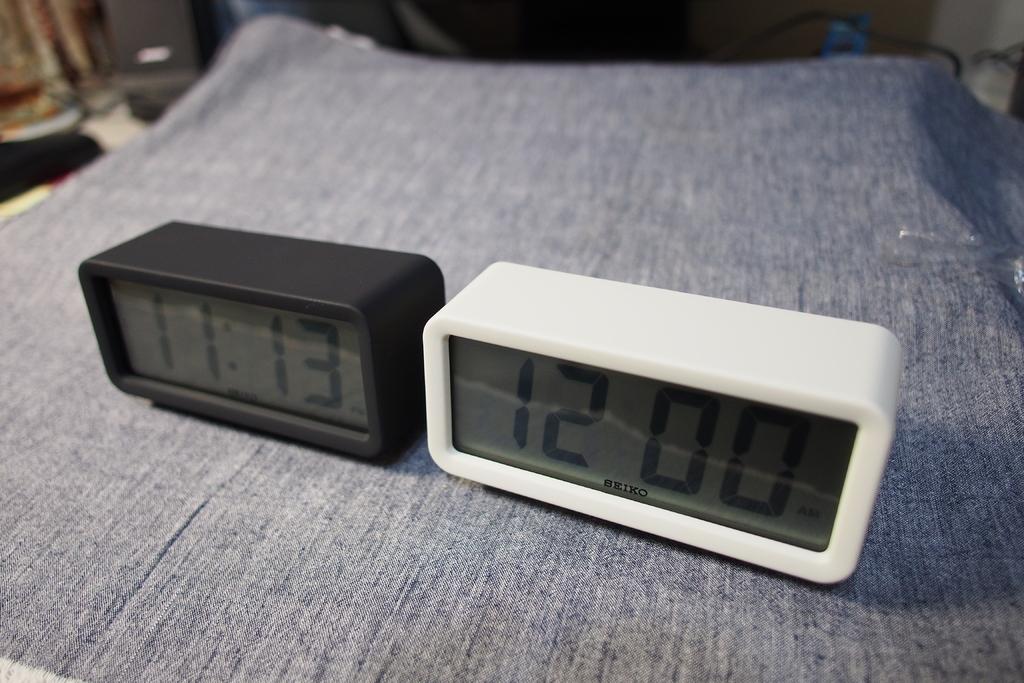What time is it on the black clock?
Your response must be concise. 11:13. What time does it say on the clock on the right (white)?
Offer a terse response. 12:00. 